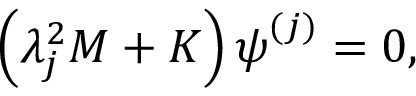<formula> <loc_0><loc_0><loc_500><loc_500>\left ( \lambda _ { j } ^ { 2 } M + K \right ) \psi ^ { ( j ) } = 0 ,</formula> 